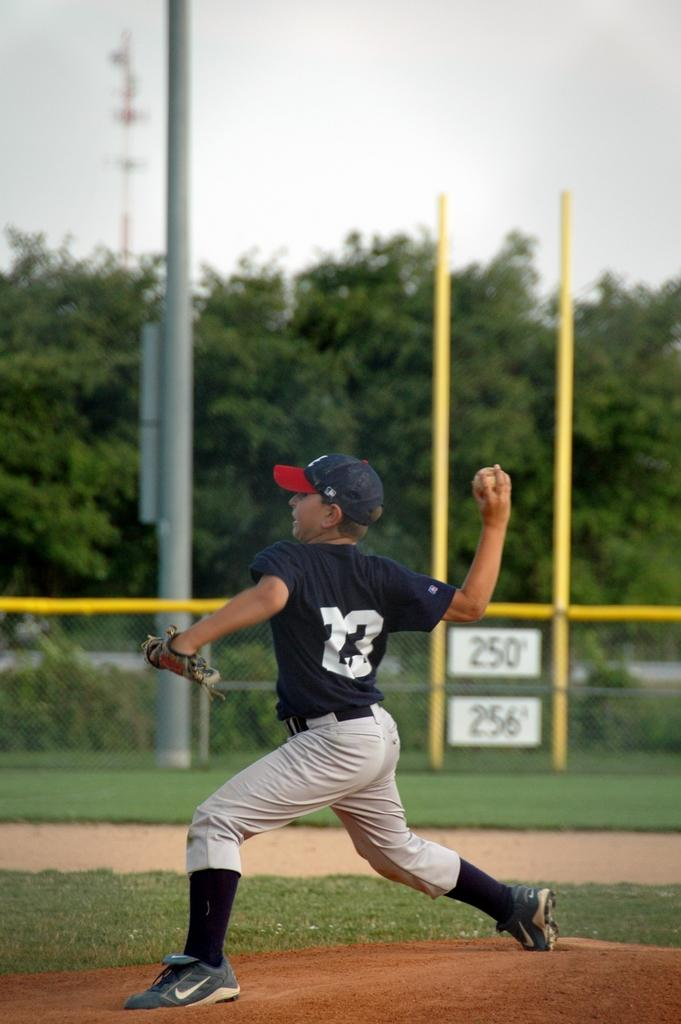Provide a one-sentence caption for the provided image. A boy in a 22 shirt playing baseball and throwing a ball. 